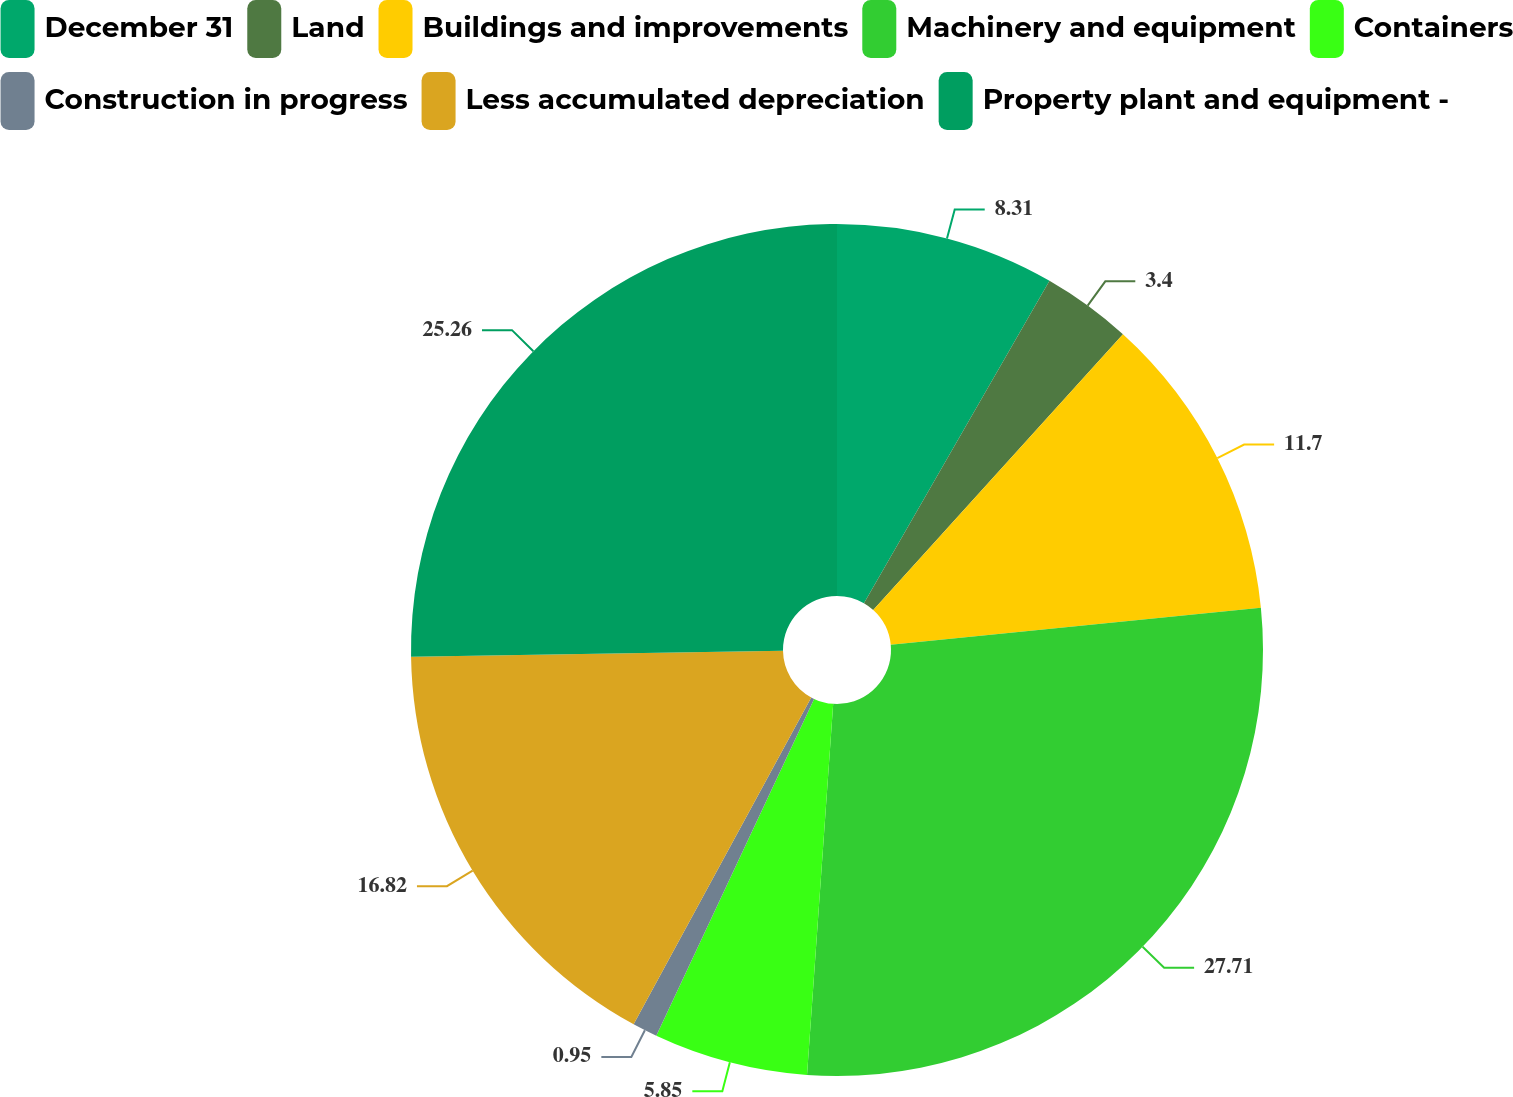Convert chart. <chart><loc_0><loc_0><loc_500><loc_500><pie_chart><fcel>December 31<fcel>Land<fcel>Buildings and improvements<fcel>Machinery and equipment<fcel>Containers<fcel>Construction in progress<fcel>Less accumulated depreciation<fcel>Property plant and equipment -<nl><fcel>8.31%<fcel>3.4%<fcel>11.7%<fcel>27.7%<fcel>5.85%<fcel>0.95%<fcel>16.82%<fcel>25.25%<nl></chart> 